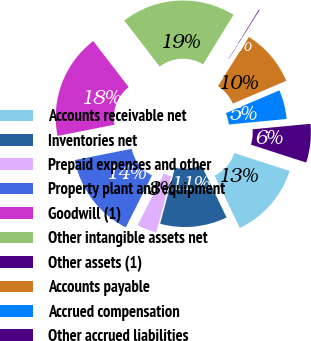Convert chart to OTSL. <chart><loc_0><loc_0><loc_500><loc_500><pie_chart><fcel>Accounts receivable net<fcel>Inventories net<fcel>Prepaid expenses and other<fcel>Property plant and equipment<fcel>Goodwill (1)<fcel>Other intangible assets net<fcel>Other assets (1)<fcel>Accounts payable<fcel>Accrued compensation<fcel>Other accrued liabilities<nl><fcel>12.87%<fcel>11.27%<fcel>3.31%<fcel>14.46%<fcel>17.65%<fcel>19.24%<fcel>0.12%<fcel>9.68%<fcel>4.9%<fcel>6.49%<nl></chart> 